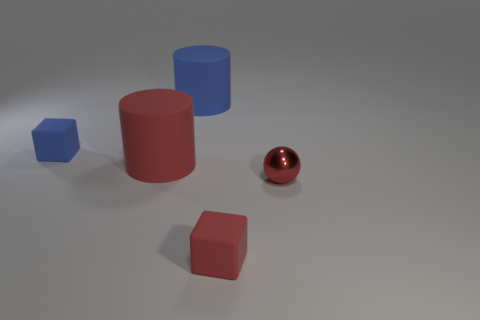What size is the thing that is right of the large blue matte cylinder and left of the tiny metallic sphere?
Ensure brevity in your answer.  Small. Is the color of the matte block left of the blue rubber cylinder the same as the large matte object that is behind the tiny blue thing?
Offer a terse response. Yes. How many tiny red rubber things are in front of the red metal ball?
Offer a terse response. 1. There is a blue thing in front of the blue rubber thing on the right side of the tiny blue rubber thing; are there any tiny cubes that are to the right of it?
Offer a very short reply. Yes. How many red cylinders are the same size as the red rubber block?
Your answer should be very brief. 0. What is the material of the small red object that is to the right of the small block in front of the tiny metal object?
Your response must be concise. Metal. There is a big thing that is in front of the big object behind the small object left of the small red block; what is its shape?
Keep it short and to the point. Cylinder. Does the tiny rubber thing that is to the left of the red cylinder have the same shape as the small matte thing that is in front of the tiny blue object?
Offer a terse response. Yes. How many other things are there of the same material as the tiny red sphere?
Offer a very short reply. 0. There is a red object that is made of the same material as the small red cube; what shape is it?
Provide a short and direct response. Cylinder. 